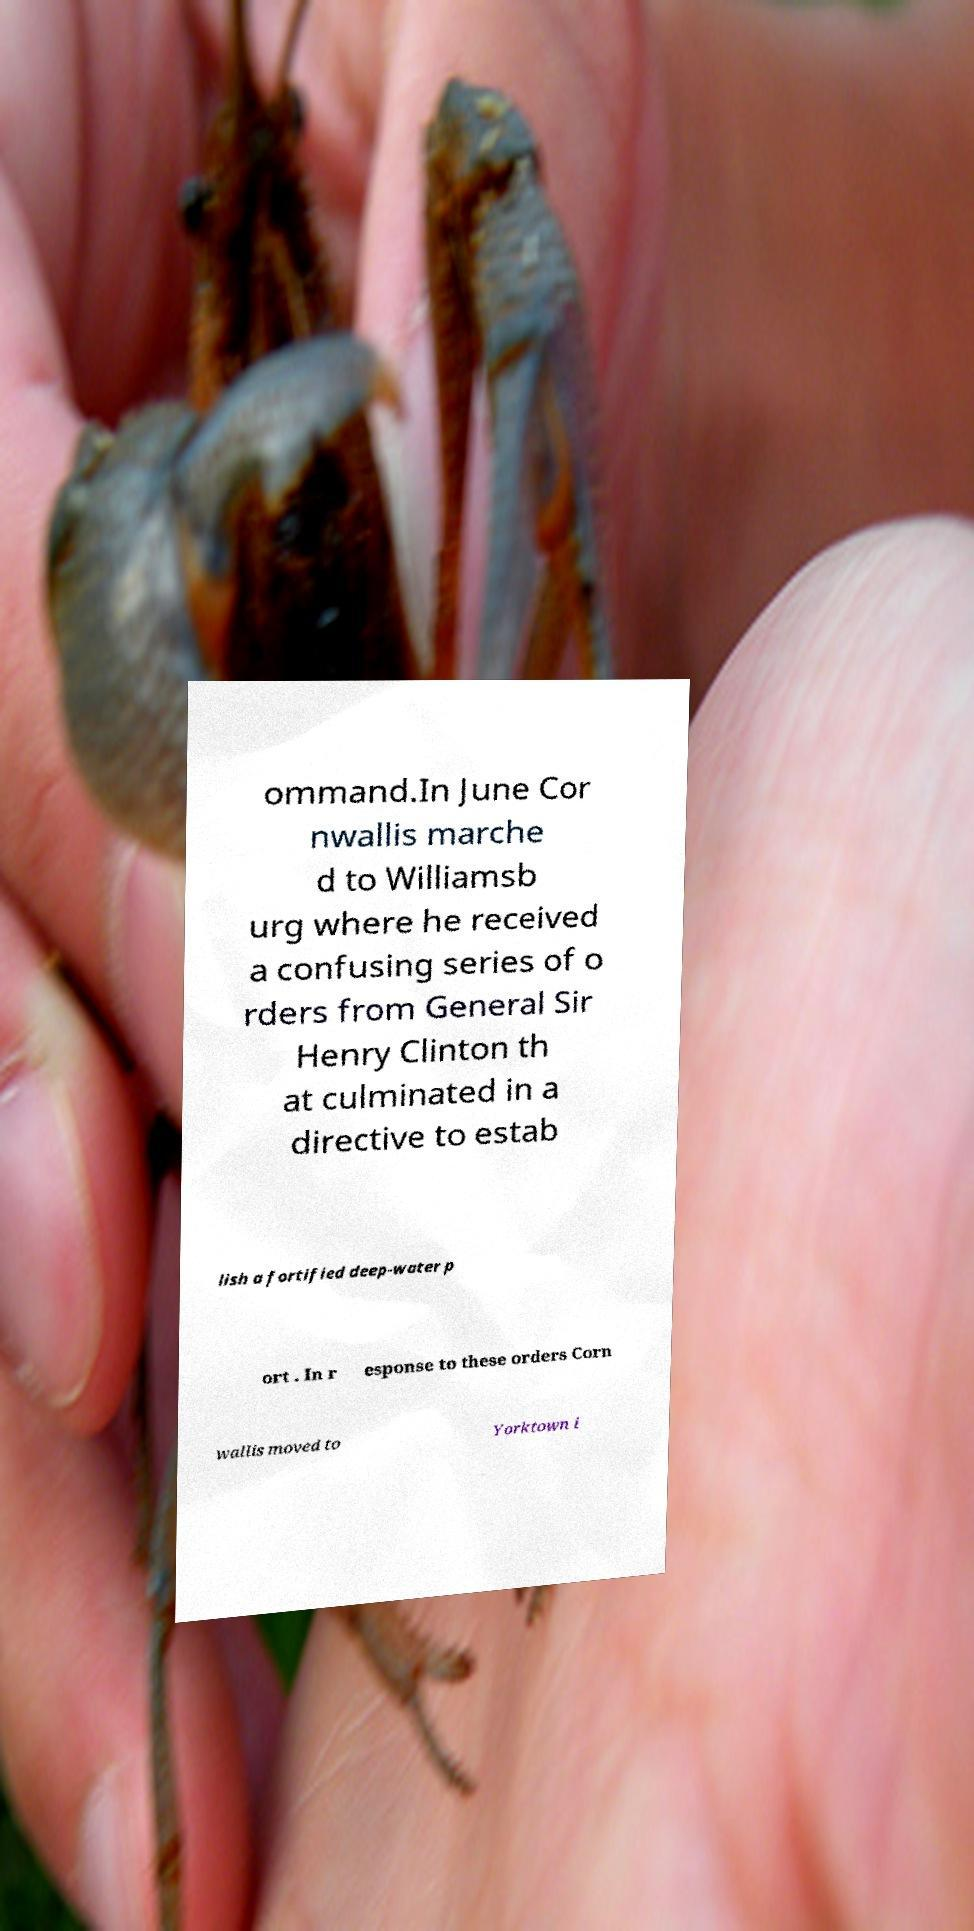Please read and relay the text visible in this image. What does it say? ommand.In June Cor nwallis marche d to Williamsb urg where he received a confusing series of o rders from General Sir Henry Clinton th at culminated in a directive to estab lish a fortified deep-water p ort . In r esponse to these orders Corn wallis moved to Yorktown i 